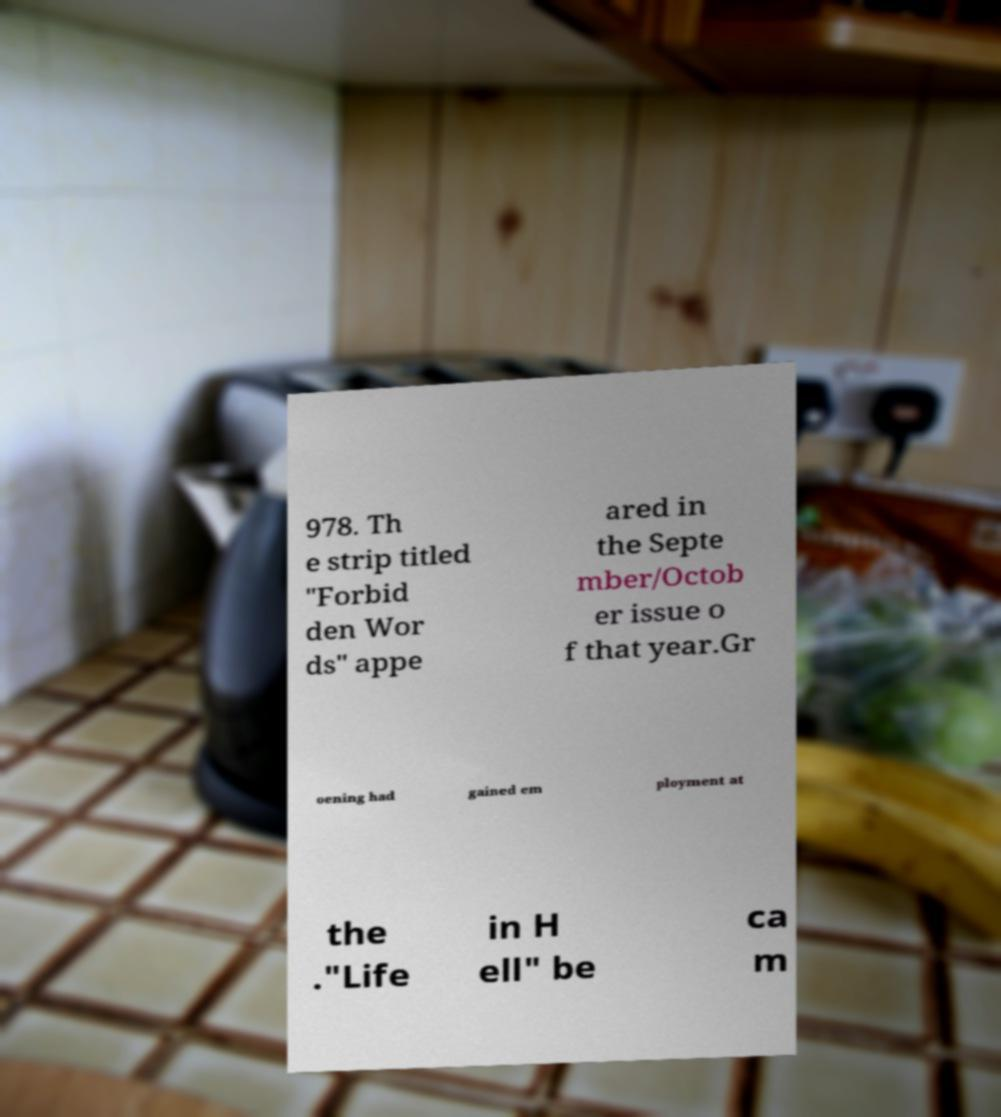Please read and relay the text visible in this image. What does it say? 978. Th e strip titled "Forbid den Wor ds" appe ared in the Septe mber/Octob er issue o f that year.Gr oening had gained em ployment at the ."Life in H ell" be ca m 